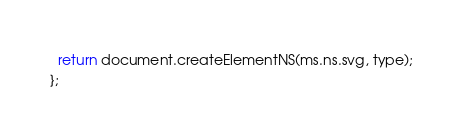<code> <loc_0><loc_0><loc_500><loc_500><_JavaScript_>  return document.createElementNS(ms.ns.svg, type);
};
</code> 